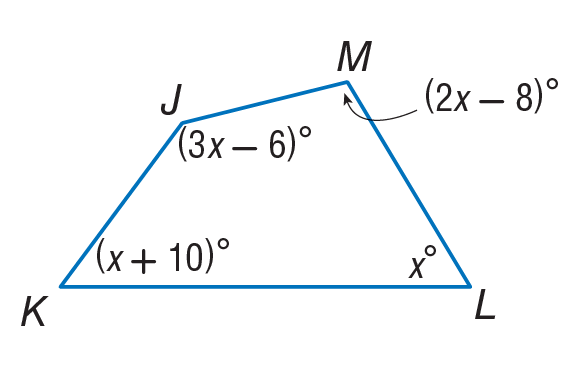Question: Find m \angle L.
Choices:
A. 52
B. 62
C. 96
D. 150
Answer with the letter. Answer: A Question: Find m \angle J.
Choices:
A. 52
B. 62
C. 72
D. 150
Answer with the letter. Answer: D Question: Find m \angle M.
Choices:
A. 62
B. 71
C. 96
D. 106
Answer with the letter. Answer: C Question: Find m \angle K.
Choices:
A. 62
B. 72
C. 116
D. 160
Answer with the letter. Answer: A 